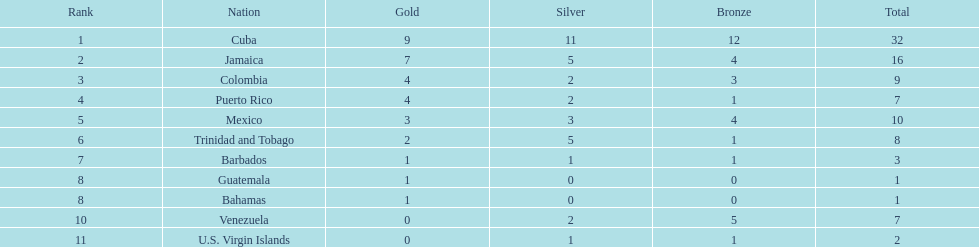What is the difference in medals between cuba and mexico? 22. 